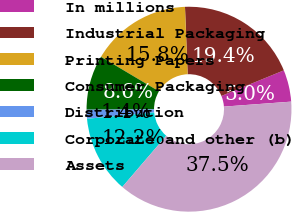Convert chart. <chart><loc_0><loc_0><loc_500><loc_500><pie_chart><fcel>In millions<fcel>Industrial Packaging<fcel>Printing Papers<fcel>Consumer Packaging<fcel>Distribution<fcel>Corporate and other (b)<fcel>Assets<nl><fcel>5.01%<fcel>19.44%<fcel>15.83%<fcel>8.62%<fcel>1.41%<fcel>12.23%<fcel>37.46%<nl></chart> 